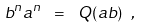<formula> <loc_0><loc_0><loc_500><loc_500>b ^ { n } a ^ { n } \ = \ Q ( a b ) \ ,</formula> 